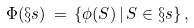<formula> <loc_0><loc_0><loc_500><loc_500>\Phi ( \S s ) \, = \, \{ \phi ( S ) \, | \, S \in \S s \} \, ,</formula> 